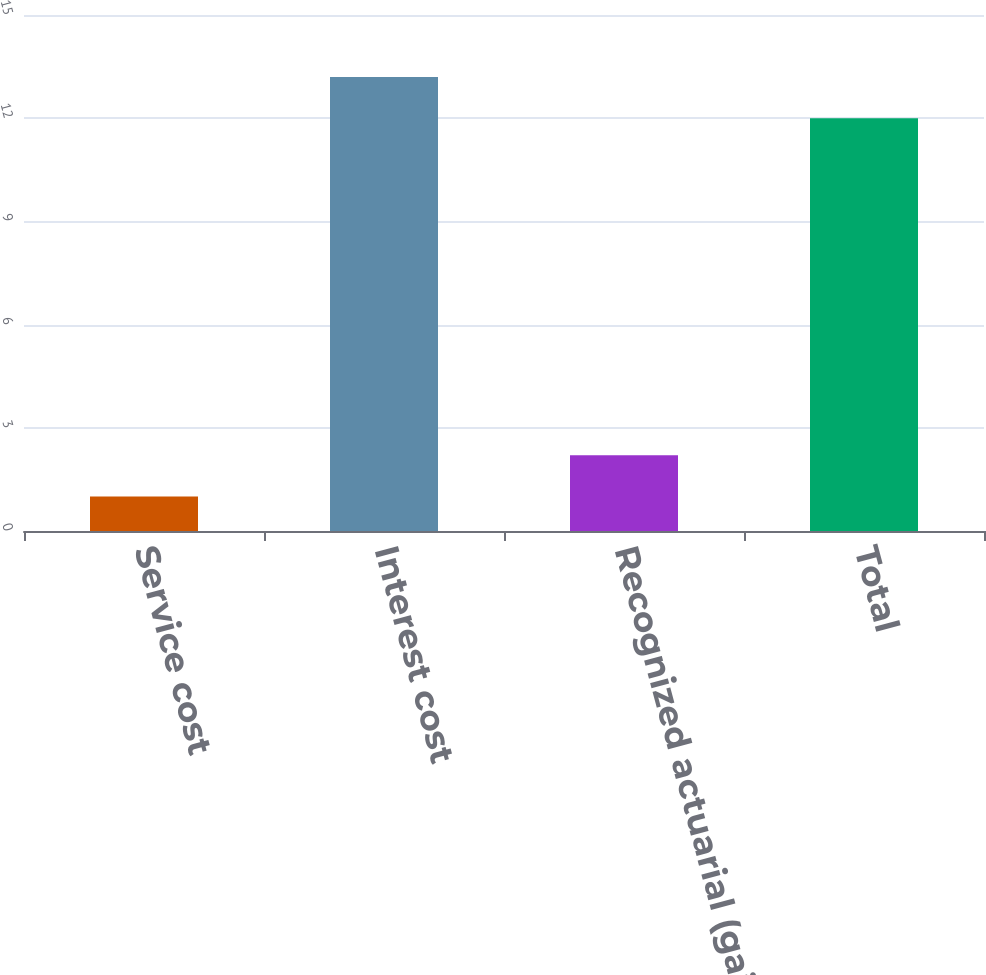<chart> <loc_0><loc_0><loc_500><loc_500><bar_chart><fcel>Service cost<fcel>Interest cost<fcel>Recognized actuarial (gain)<fcel>Total<nl><fcel>1<fcel>13.2<fcel>2.2<fcel>12<nl></chart> 